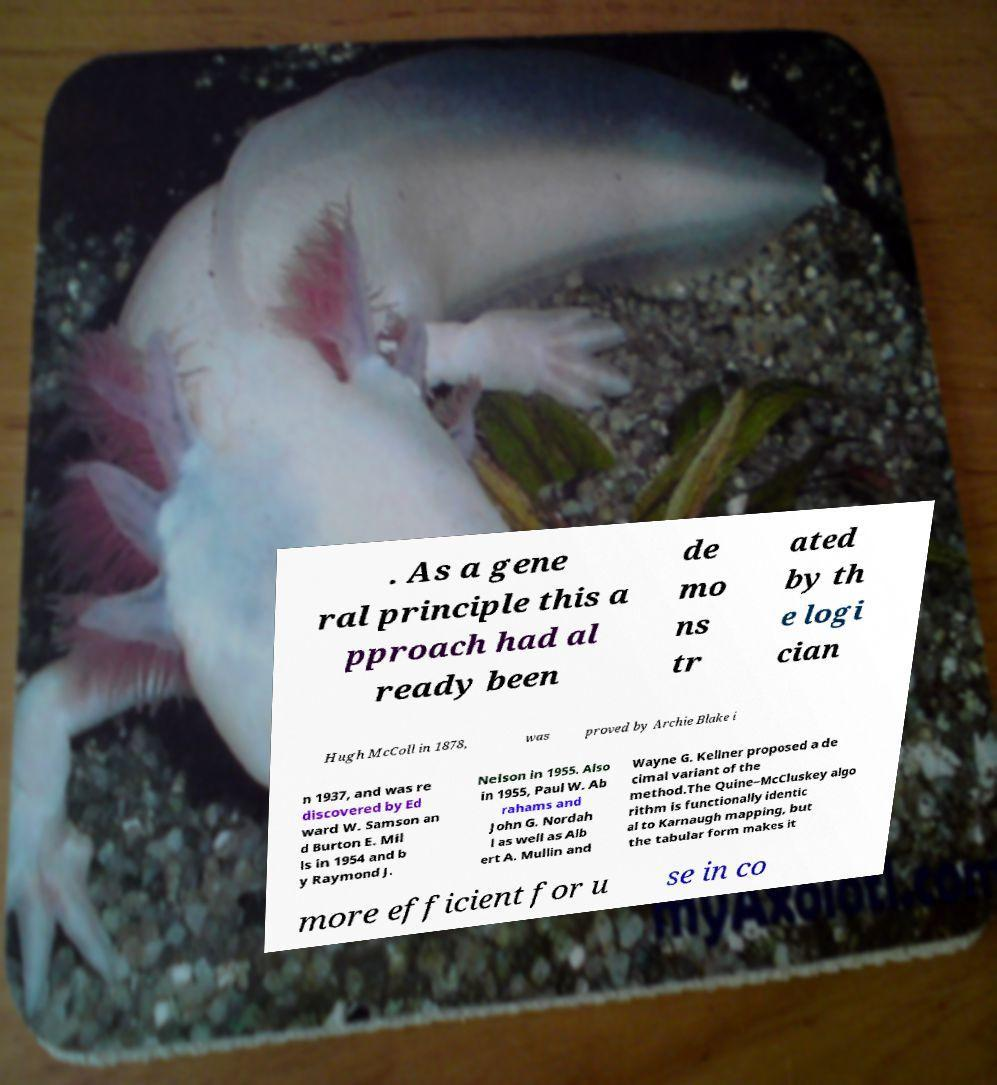What messages or text are displayed in this image? I need them in a readable, typed format. . As a gene ral principle this a pproach had al ready been de mo ns tr ated by th e logi cian Hugh McColl in 1878, was proved by Archie Blake i n 1937, and was re discovered by Ed ward W. Samson an d Burton E. Mil ls in 1954 and b y Raymond J. Nelson in 1955. Also in 1955, Paul W. Ab rahams and John G. Nordah l as well as Alb ert A. Mullin and Wayne G. Kellner proposed a de cimal variant of the method.The Quine–McCluskey algo rithm is functionally identic al to Karnaugh mapping, but the tabular form makes it more efficient for u se in co 